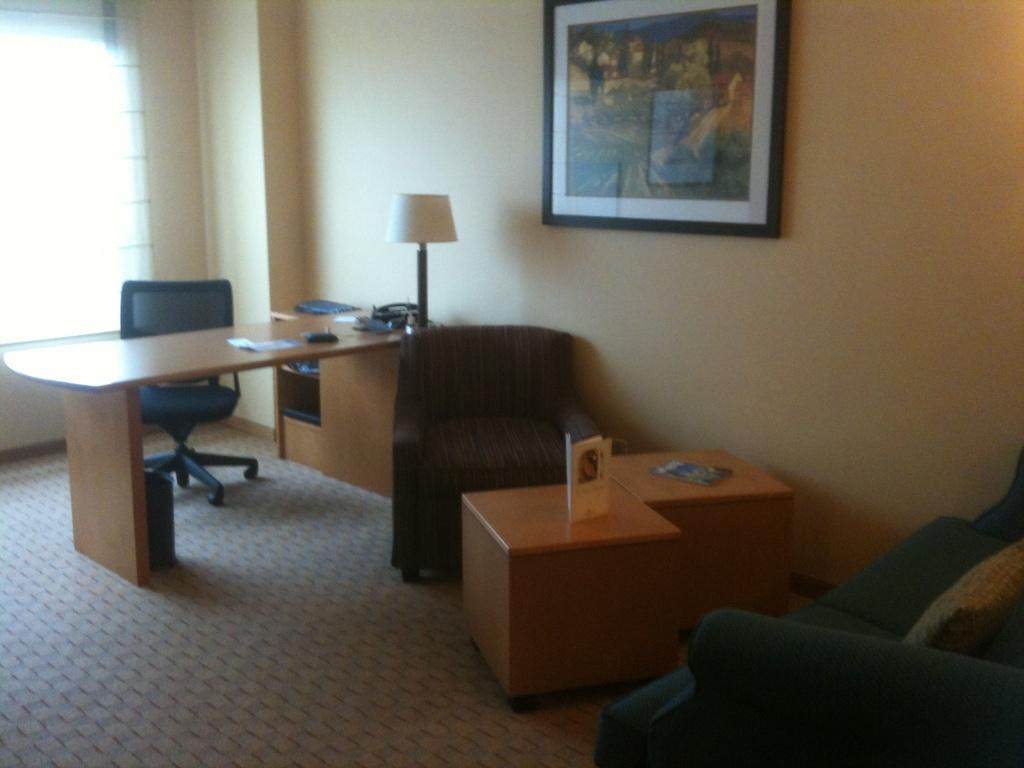What type of furniture is present in the image? There is a chair and a table in the image. How are the chair and table arranged in relation to each other? The table is in front of the chair. What object is on the table? There is a table lamp on the table. What can be seen on the wall in the image? There is a photo frame on the wall. What type of apparatus is being used for driving in the image? There is no apparatus for driving present in the image. What type of shop can be seen in the background of the image? There is no shop visible in the image. 